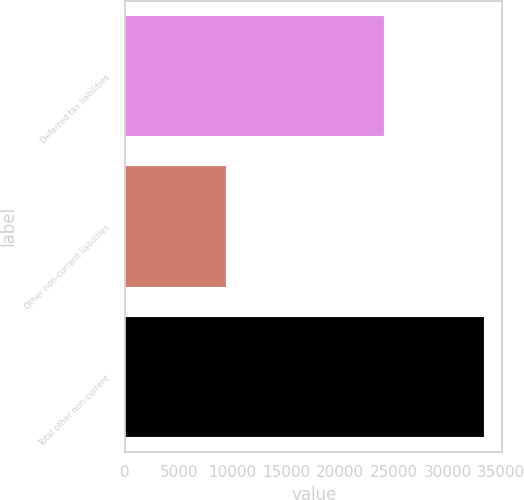Convert chart to OTSL. <chart><loc_0><loc_0><loc_500><loc_500><bar_chart><fcel>Deferred tax liabilities<fcel>Other non-current liabilities<fcel>Total other non-current<nl><fcel>24062<fcel>9365<fcel>33427<nl></chart> 